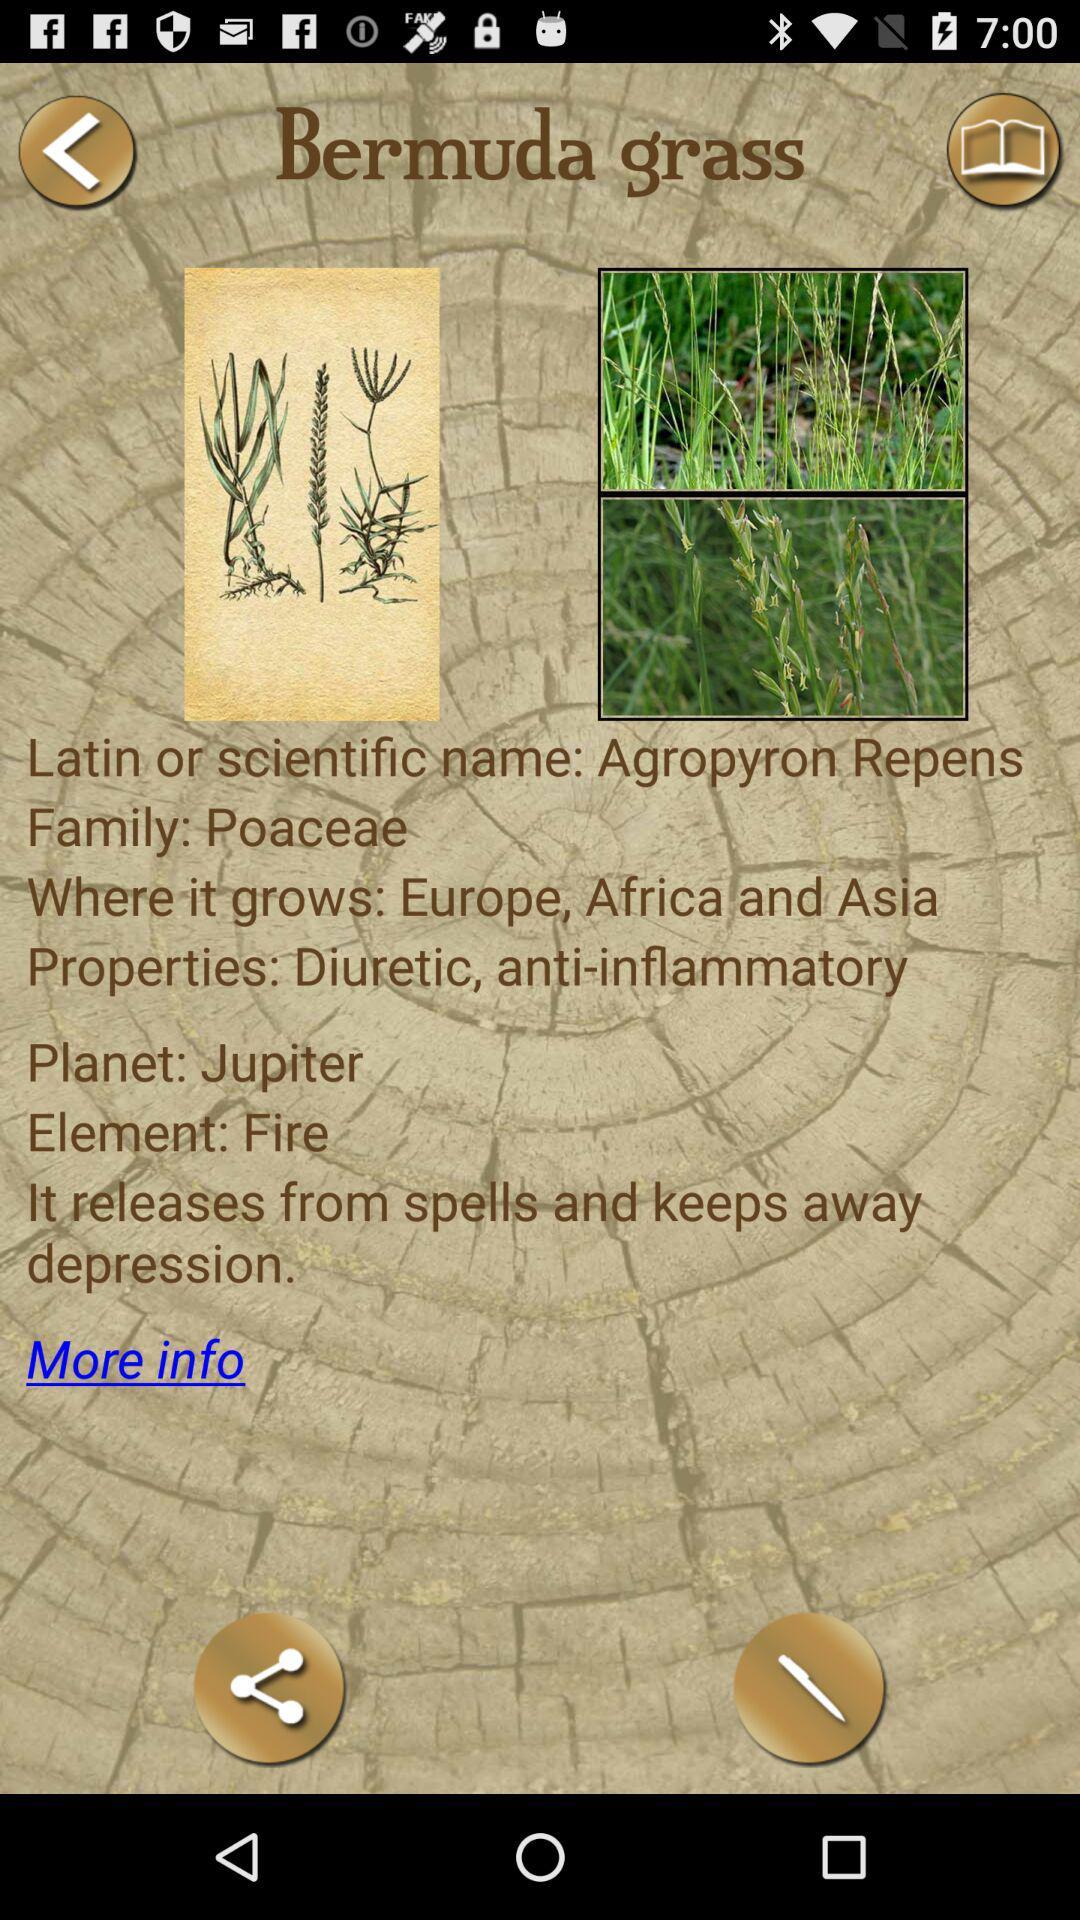What is the scientific name of Bermuda grass? The scientific name of Bermuda grass is "Agropyron Repens". 